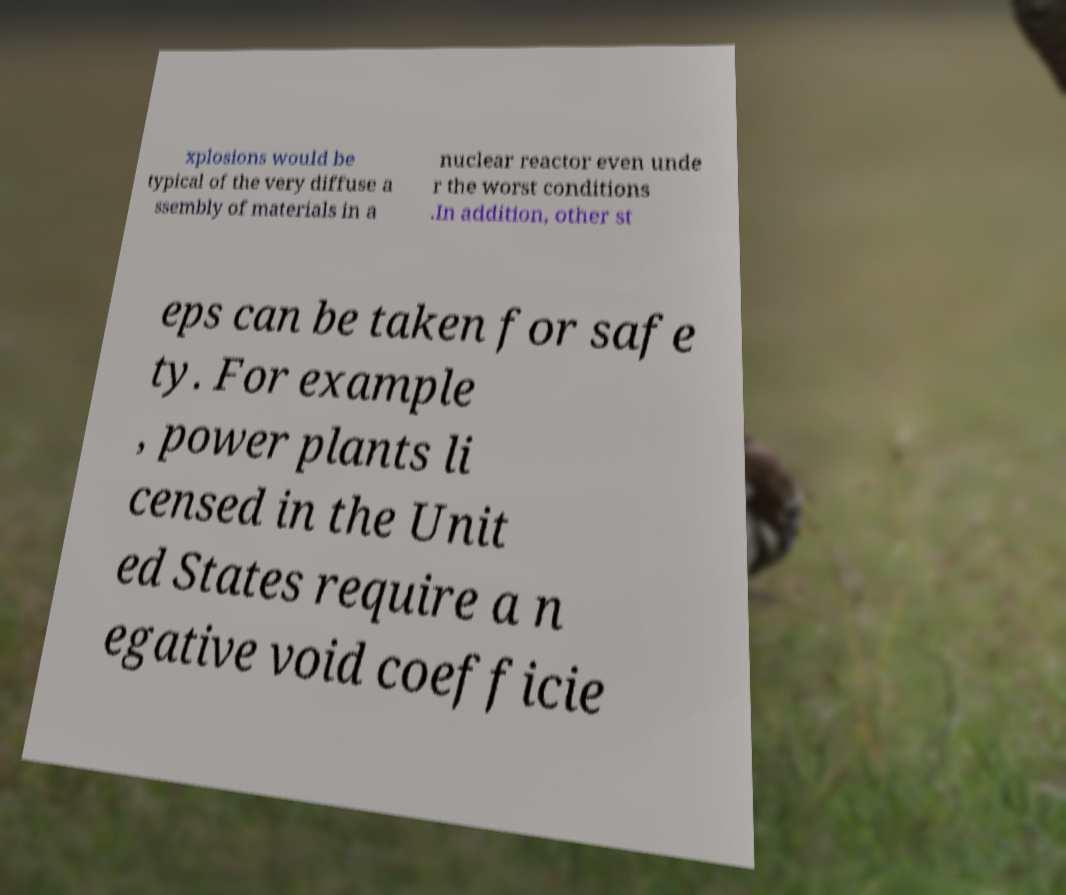Can you read and provide the text displayed in the image?This photo seems to have some interesting text. Can you extract and type it out for me? xplosions would be typical of the very diffuse a ssembly of materials in a nuclear reactor even unde r the worst conditions .In addition, other st eps can be taken for safe ty. For example , power plants li censed in the Unit ed States require a n egative void coefficie 